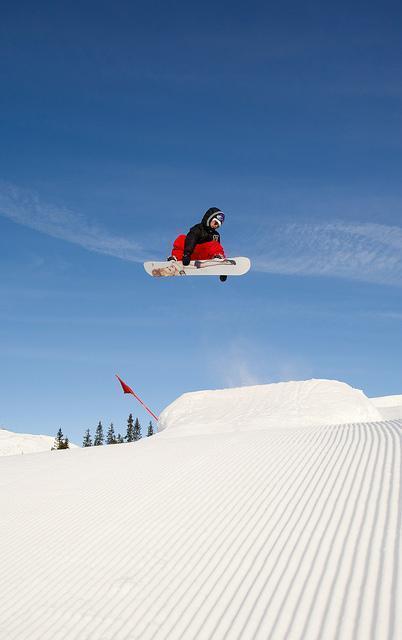How many people are shown?
Give a very brief answer. 1. 